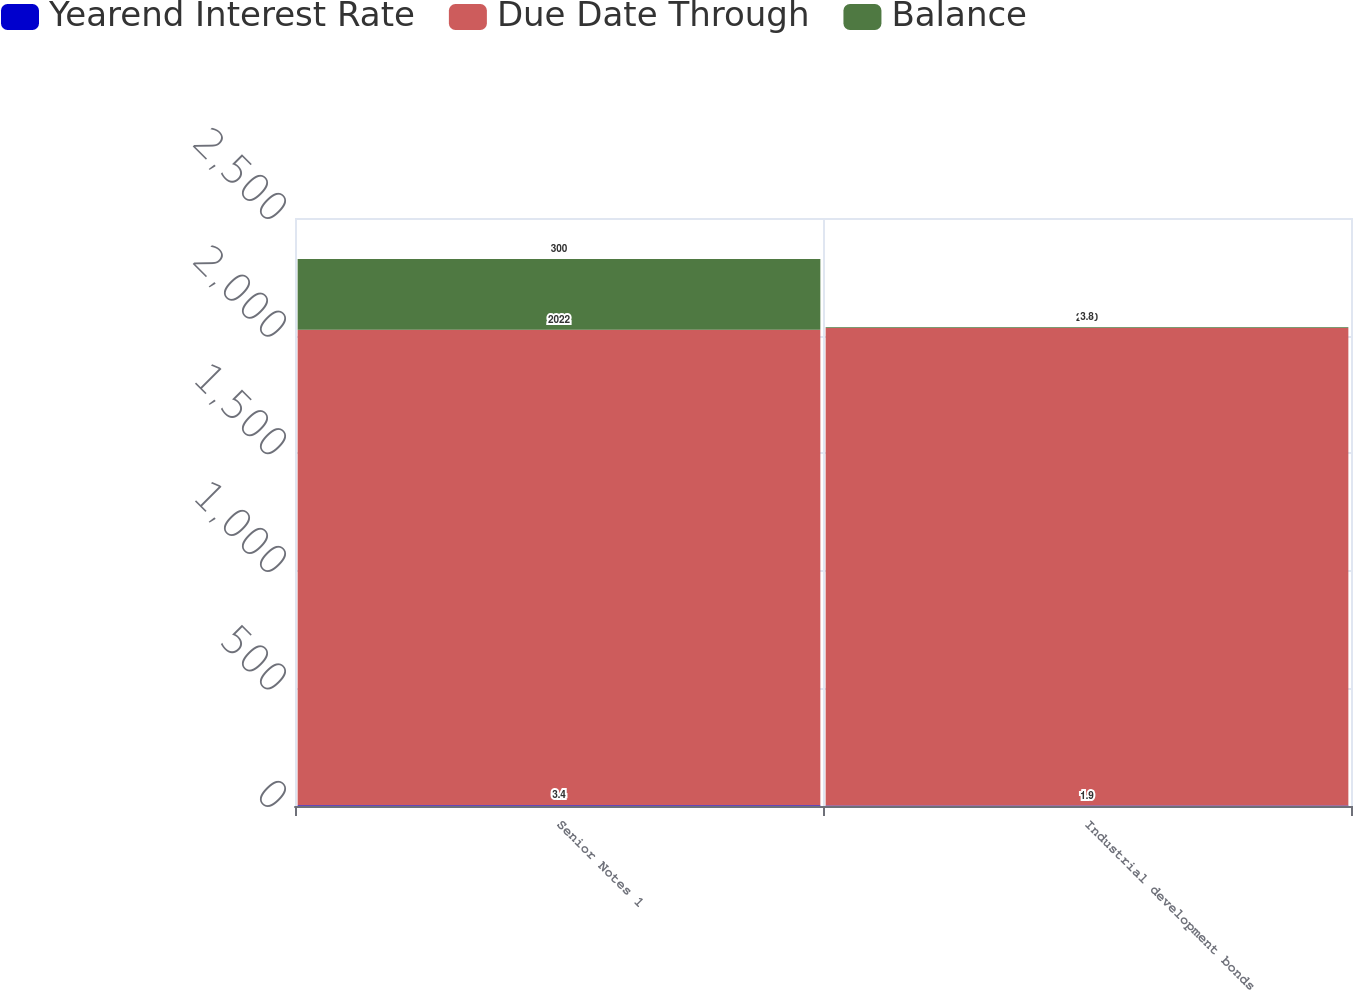Convert chart. <chart><loc_0><loc_0><loc_500><loc_500><stacked_bar_chart><ecel><fcel>Senior Notes 1<fcel>Industrial development bonds<nl><fcel>Yearend Interest Rate<fcel>3.4<fcel>1.9<nl><fcel>Due Date Through<fcel>2022<fcel>2030<nl><fcel>Balance<fcel>300<fcel>3.8<nl></chart> 